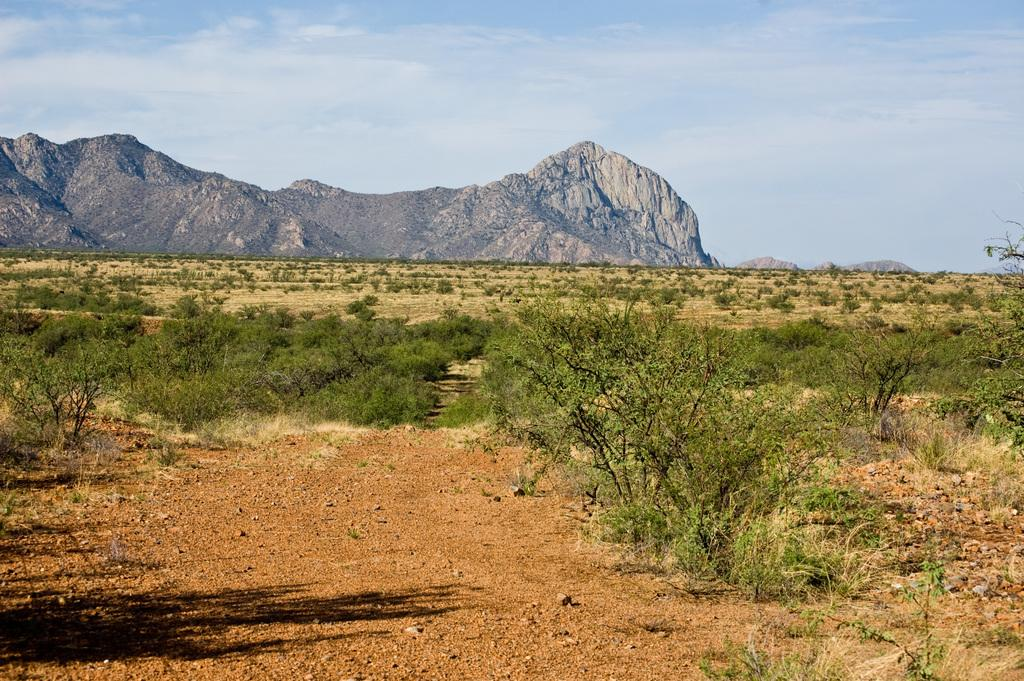What type of vegetation can be seen in the image? There are trees and plants in the image. What is the terrain like in the image? There is a hill in the image. What is visible in the background of the image? The sky is visible in the image. What can be seen in the sky? Clouds are present in the sky. What is the price of the airport in the image? There is no airport present in the image, so it is not possible to determine its price. 